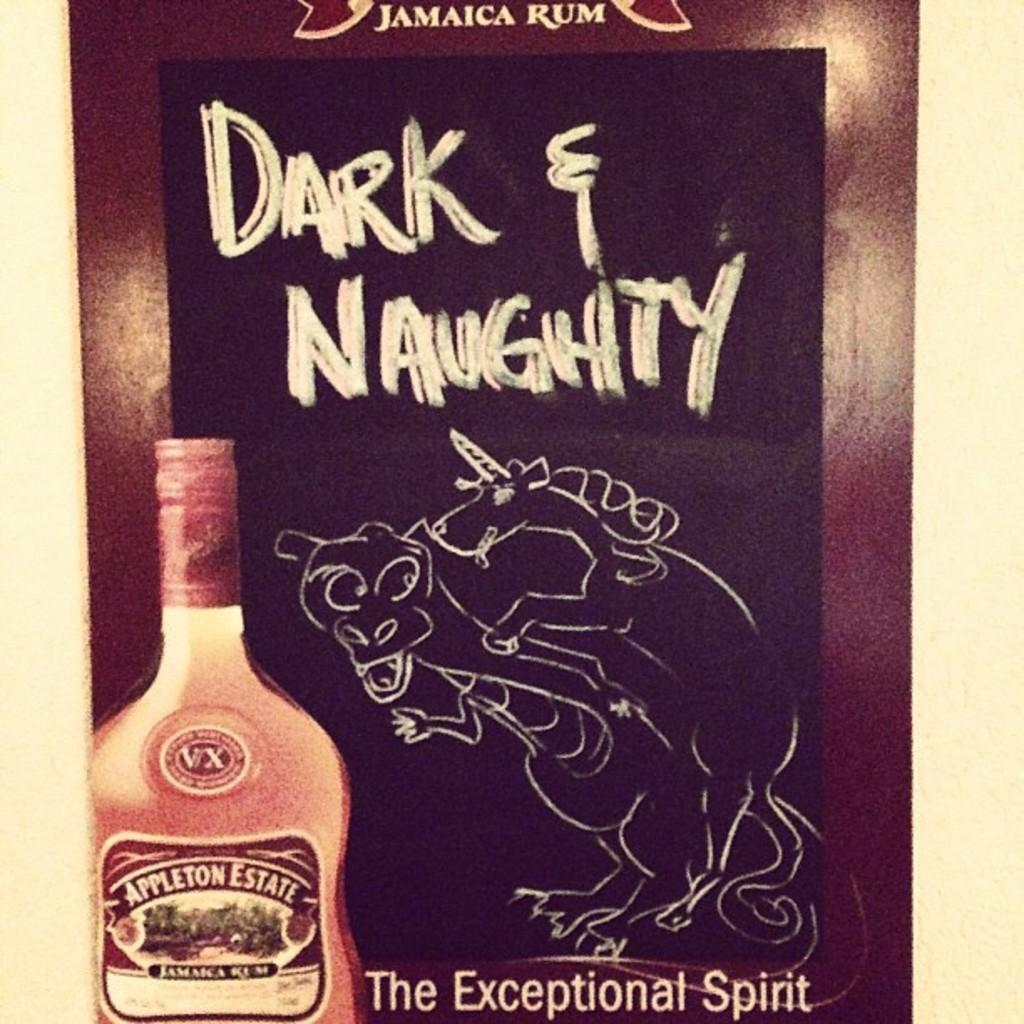<image>
Write a terse but informative summary of the picture. Bottle of Appleton Estate next to a sign that says Dark & Naughty. 